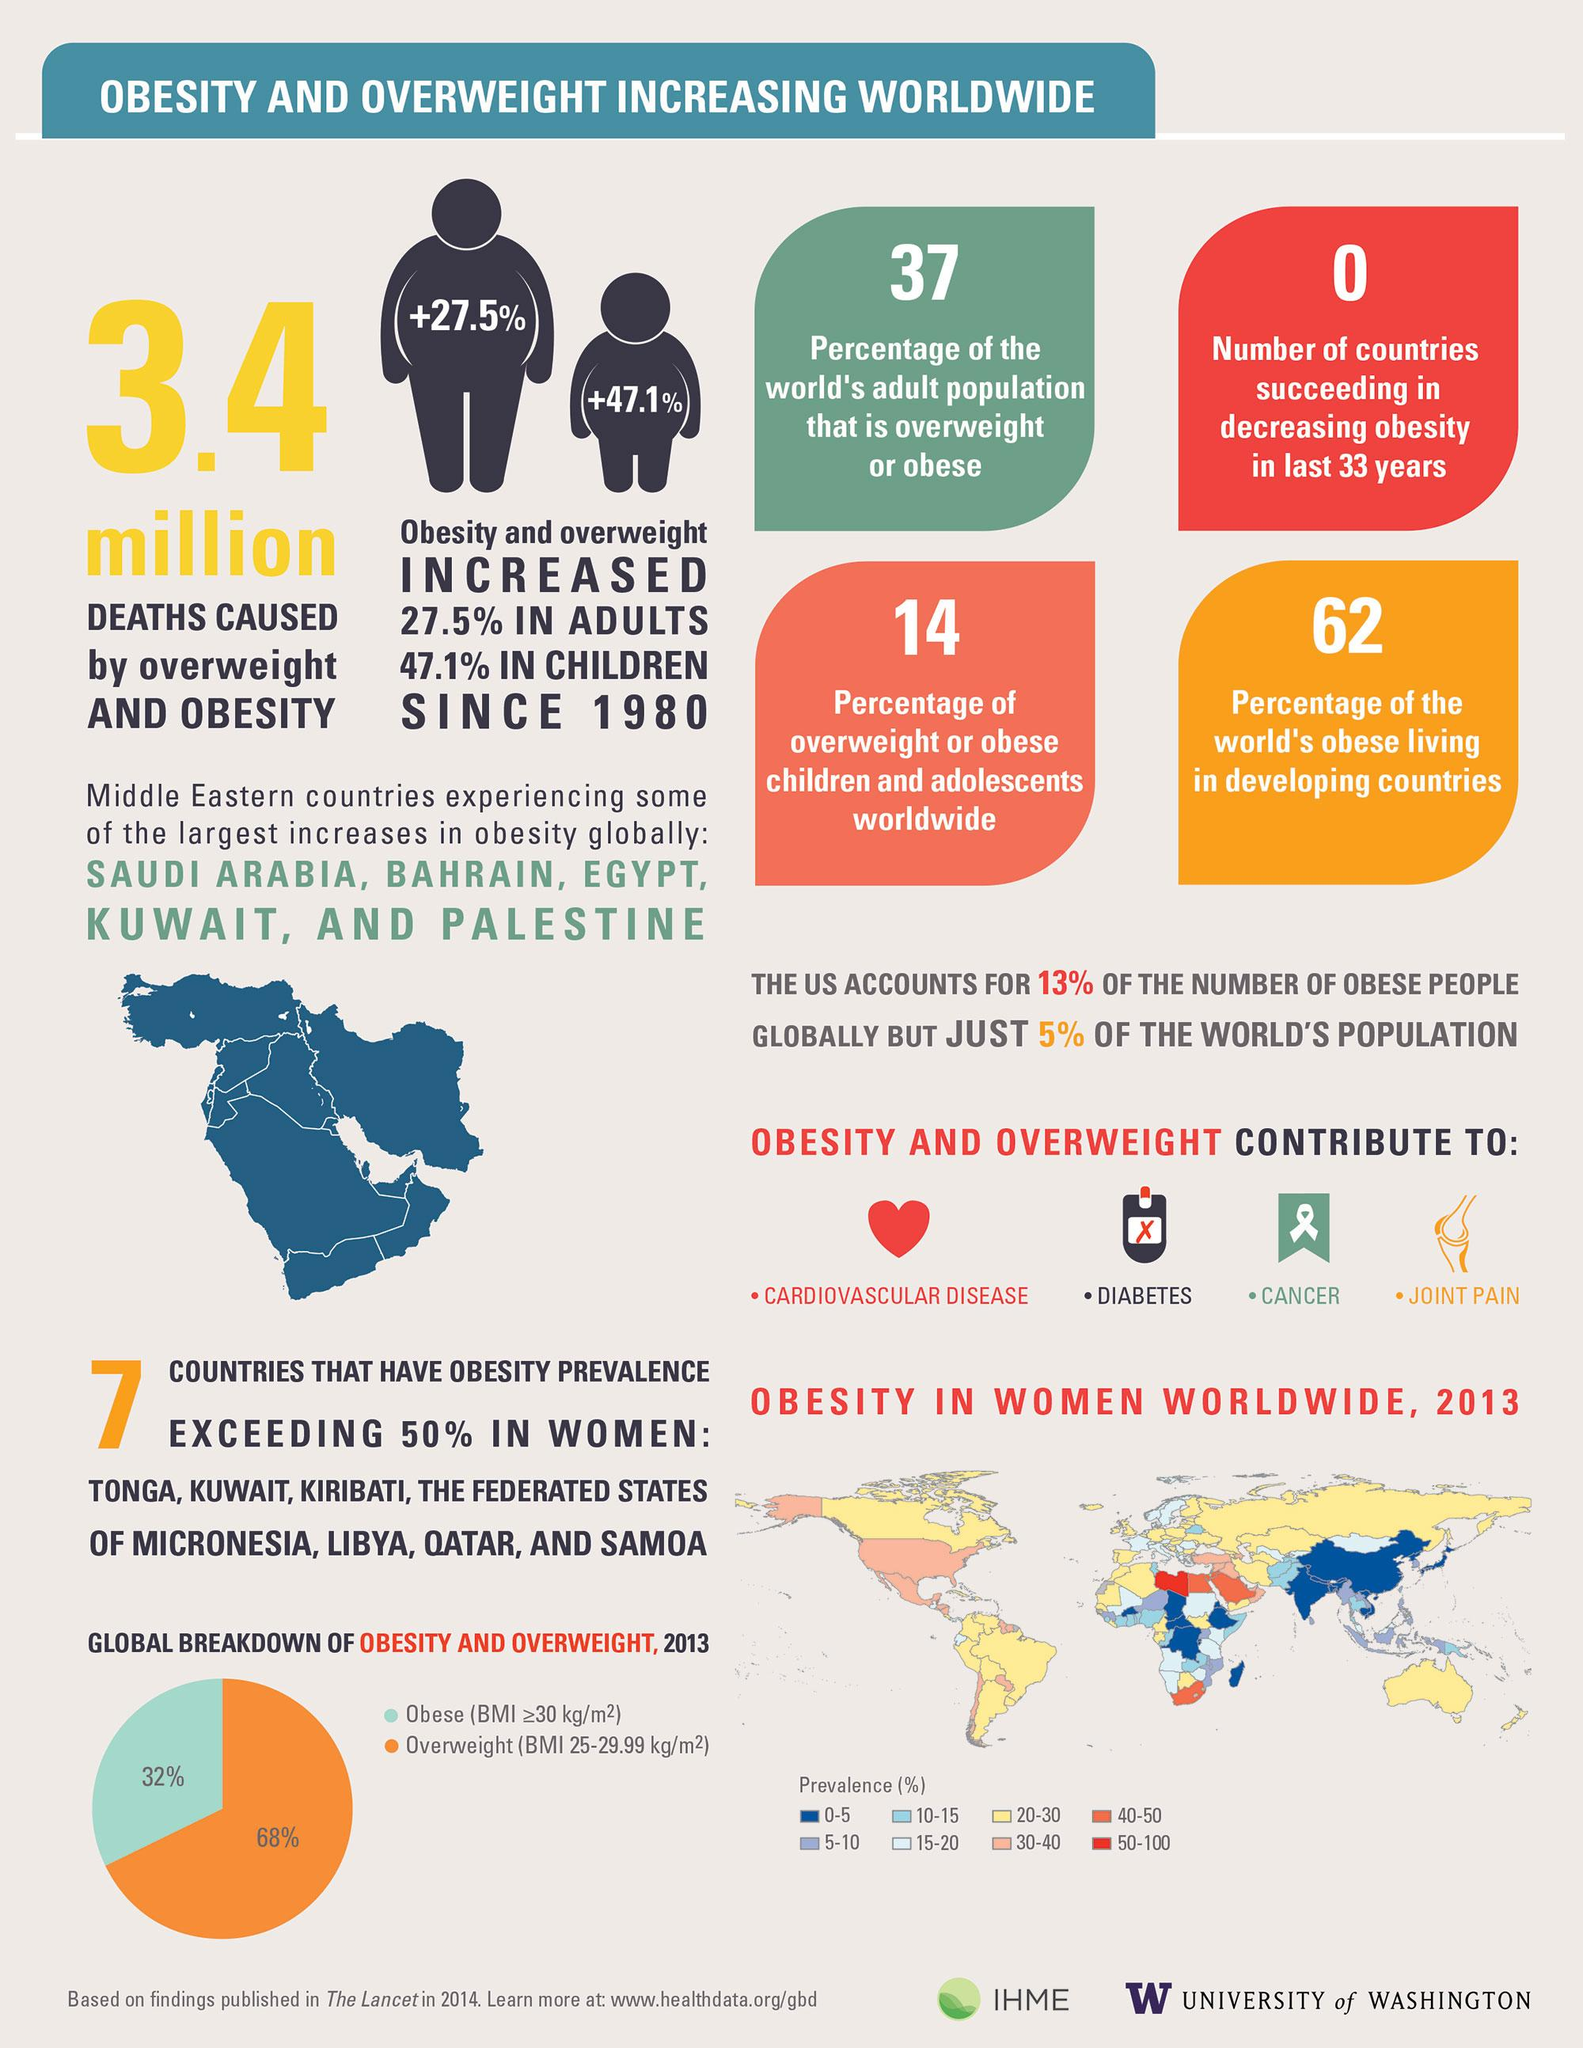Give some essential details in this illustration. According to available data, the prevalence percentage of obesity in India ranges from 0% to 5%. According to data, Libya has the highest prevalence of obesity among all countries. According to recent estimates, the prevalence of obesity in the United States is approximately 30-40%. In the United States, 51% of adults, children, and adolescents are obese or overweight. 